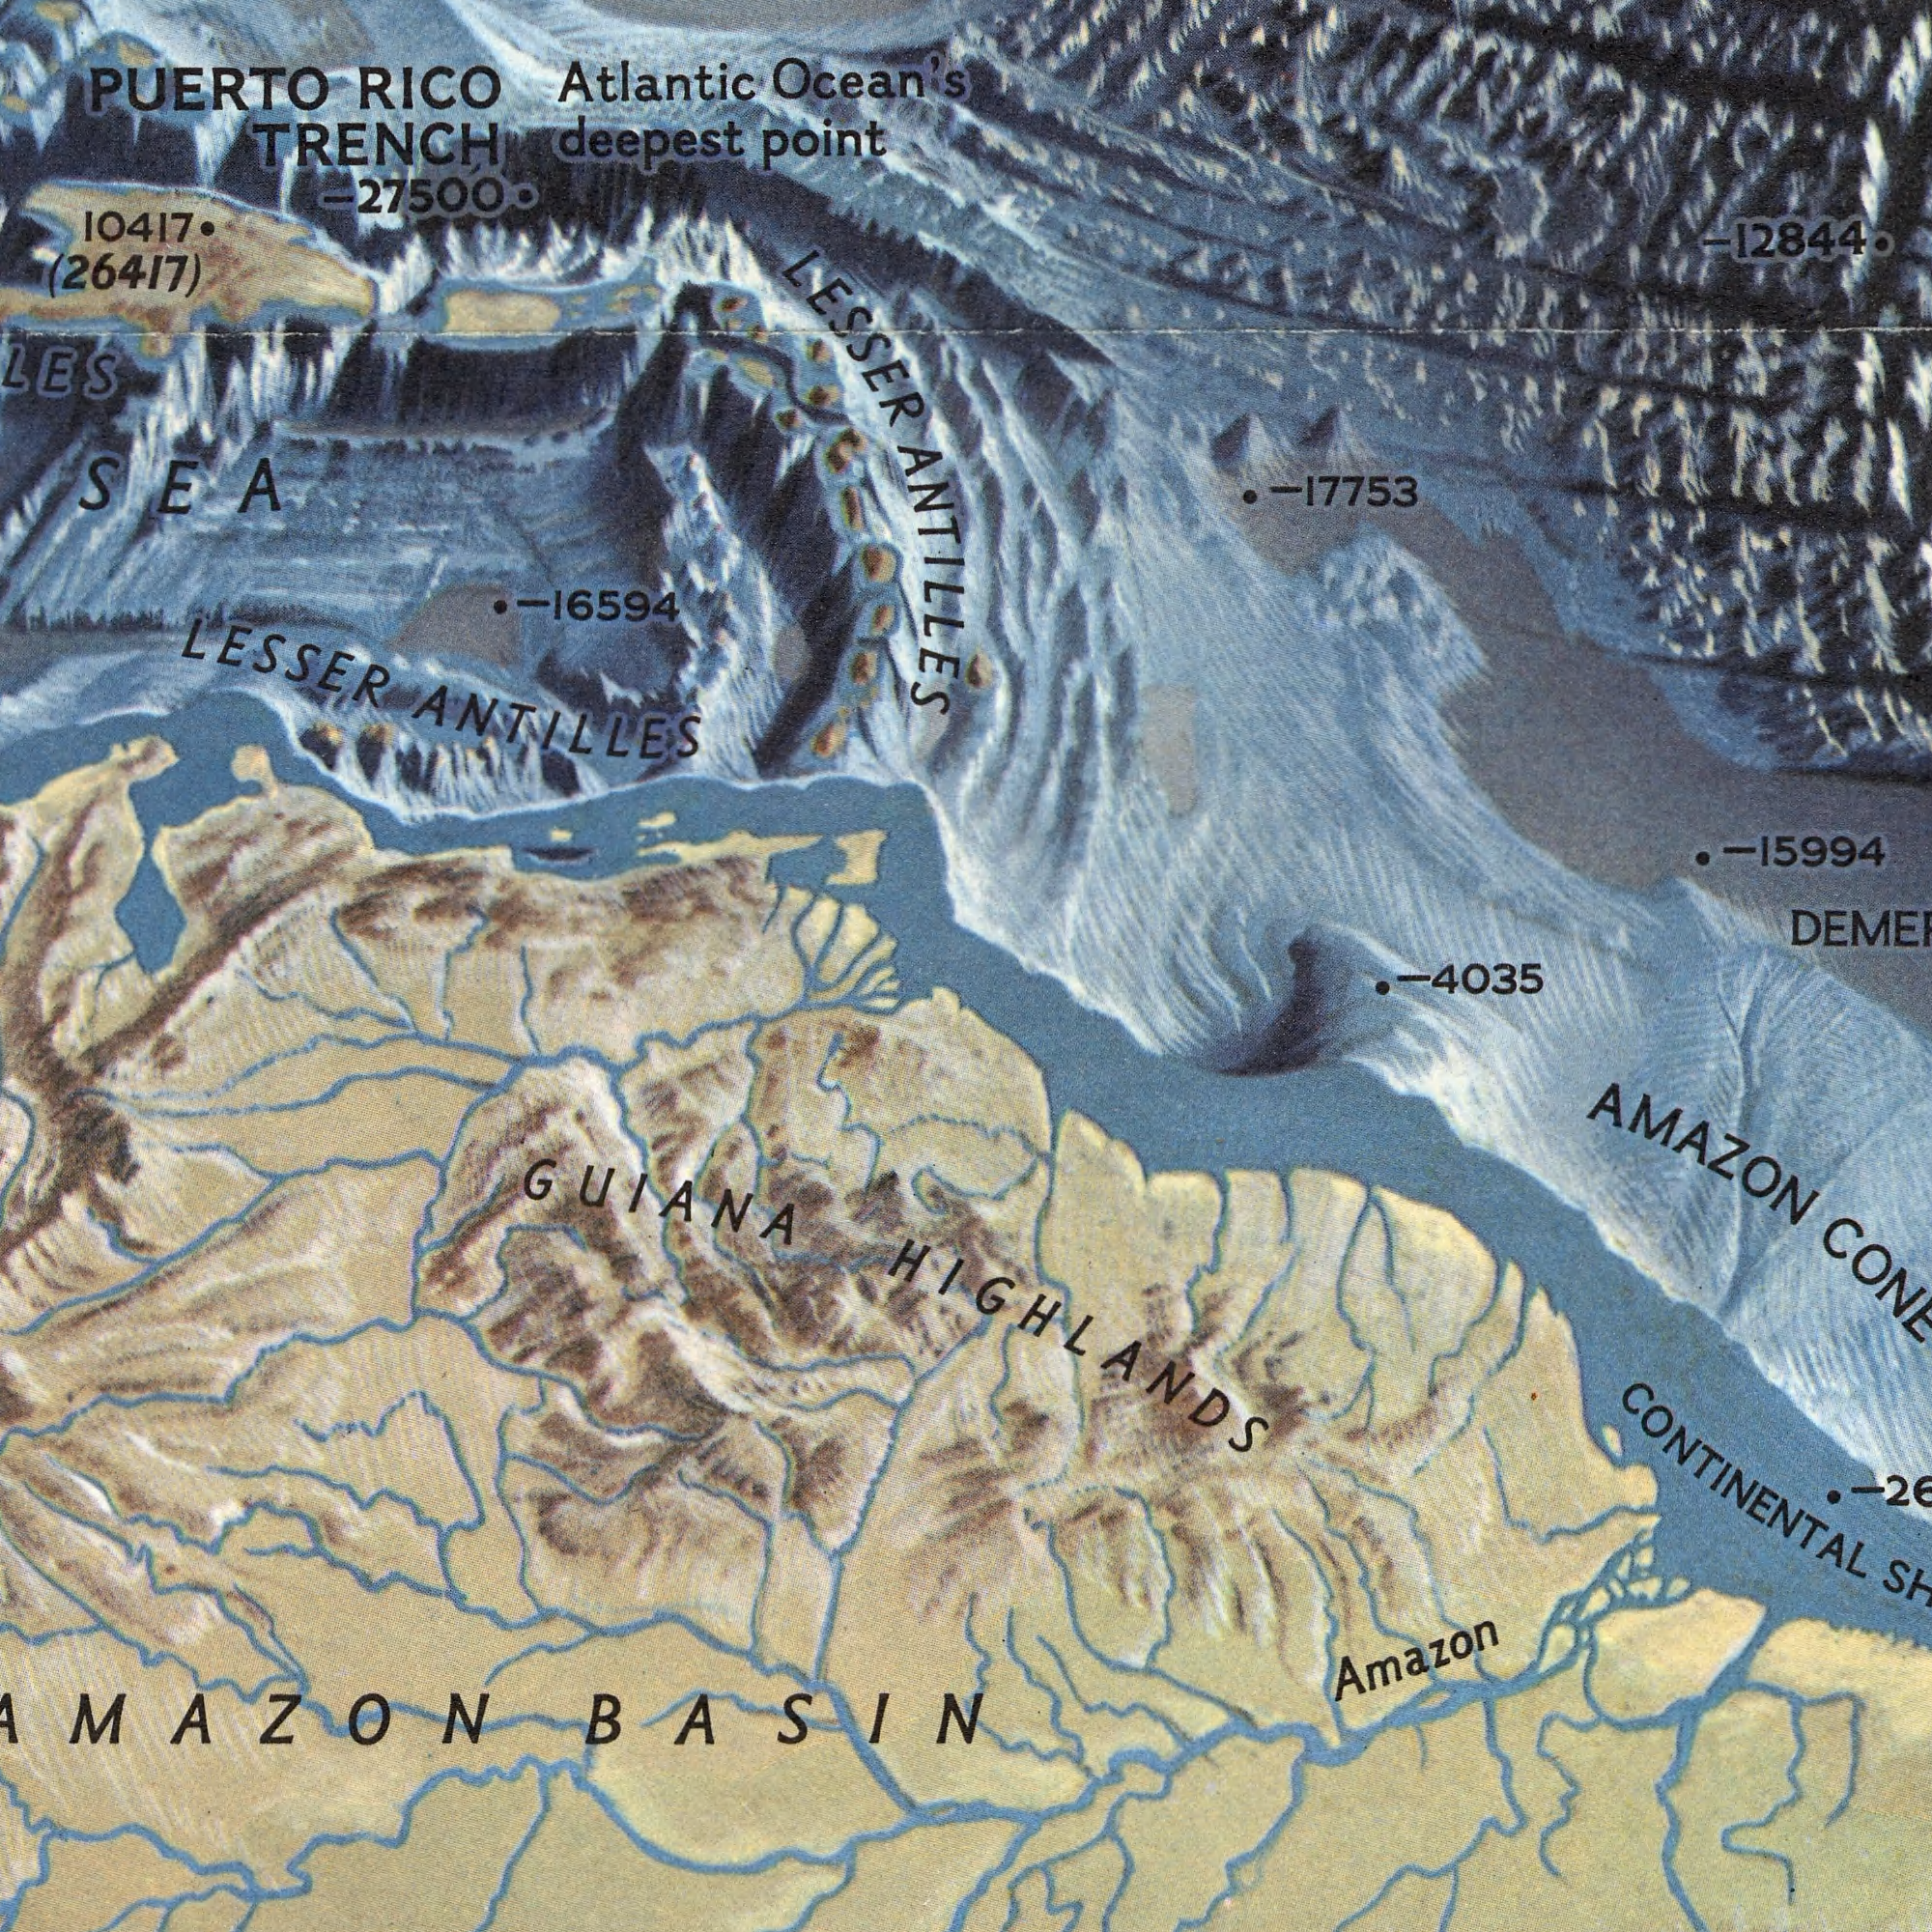What text is visible in the lower-left corner? GUIANA BASIN What text can you see in the top-left section? PUERTO point Atlantic RICO deepest LESSER 10417 ANTILLES Ocean's (26417) -16594 -27500 LESSER TRENCH ANTILLES SEA What text is visible in the lower-right corner? Amazon -4035 AMAZON CONTINENTAL HIGHLANDS What text can you see in the top-right section? -12844 -15994 -17753 